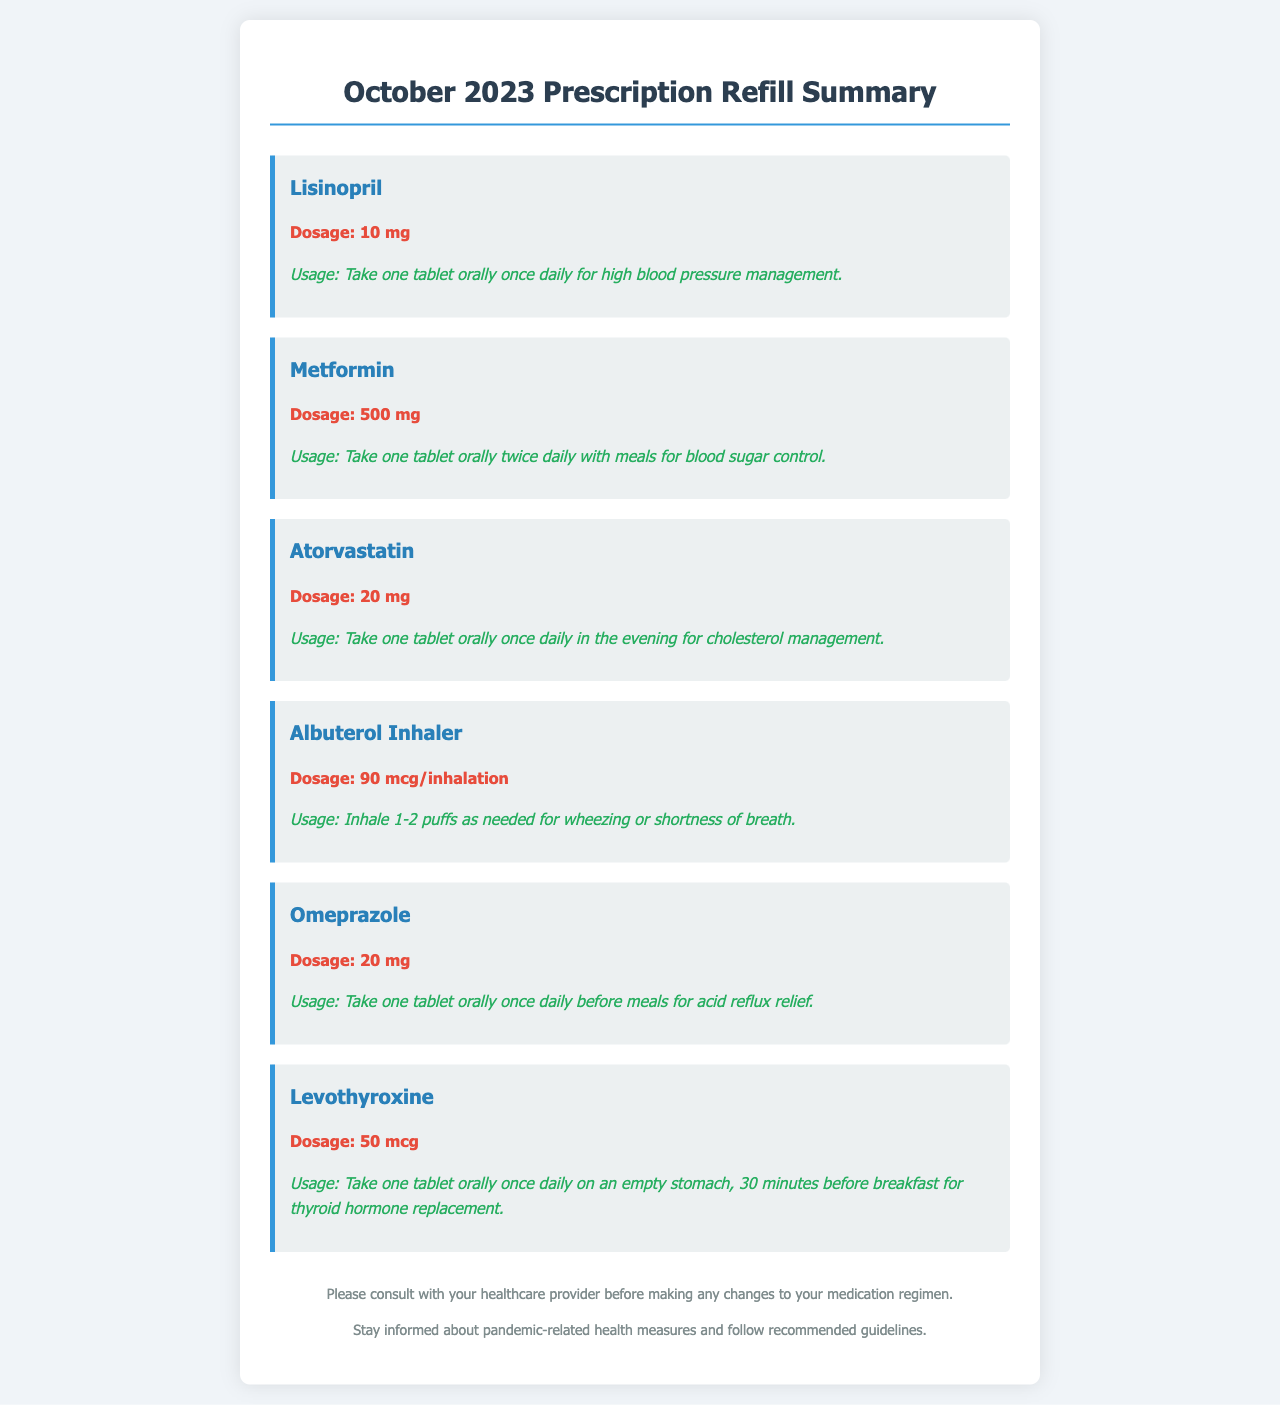What medication is prescribed for high blood pressure? The medication prescribed for high blood pressure management is listed as Lisinopril.
Answer: Lisinopril What is the dosage for Metformin? The document specifies that the dosage for Metformin is 500 mg.
Answer: 500 mg How often should Atorvastatin be taken? The usage instructions for Atorvastatin state that it should be taken once daily in the evening.
Answer: Once daily What is the recommended usage for Albuterol Inhaler? The instructions for Albuterol Inhaler indicate it should be inhaled 1-2 puffs as needed for wheezing or shortness of breath.
Answer: 1-2 puffs as needed What is the dosage of Levothyroxine? The medication Levothyroxine is prescribed at a dosage of 50 mcg.
Answer: 50 mcg How should Omeprazole be taken for acid reflux relief? Omeprazole should be taken once daily before meals as specified in the usage instructions.
Answer: Once daily before meals Which medication is taken once daily on an empty stomach? The document mentions that Levothyroxine should be taken once daily on an empty stomach.
Answer: Levothyroxine What should you do before making any changes to your medication regimen? The document advises consulting with your healthcare provider before making any medication changes.
Answer: Consult with your healthcare provider 